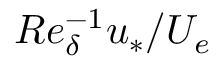<formula> <loc_0><loc_0><loc_500><loc_500>R e _ { \delta } ^ { - 1 } u _ { * } / U _ { e }</formula> 